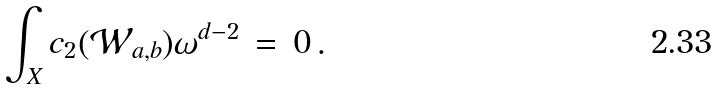<formula> <loc_0><loc_0><loc_500><loc_500>\int _ { X } c _ { 2 } ( { \mathcal { W } } _ { a , b } ) \omega ^ { d - 2 } \, = \, 0 \, .</formula> 